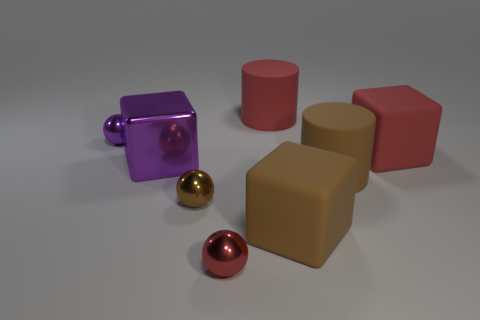Can you describe the lighting in the scene? The lighting in the image is soft and diffused, coming from above as indicated by the subtle shadows under the objects, giving the scene a calm and neutral atmosphere. 